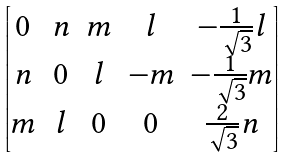<formula> <loc_0><loc_0><loc_500><loc_500>\begin{bmatrix} 0 & n & m & l & - \frac { 1 } { \sqrt { 3 } } l \\ n & 0 & l & - m & - \frac { 1 } { \sqrt { 3 } } m \\ m & l & 0 & 0 & \frac { 2 } { \sqrt { 3 } } n \\ \end{bmatrix}</formula> 